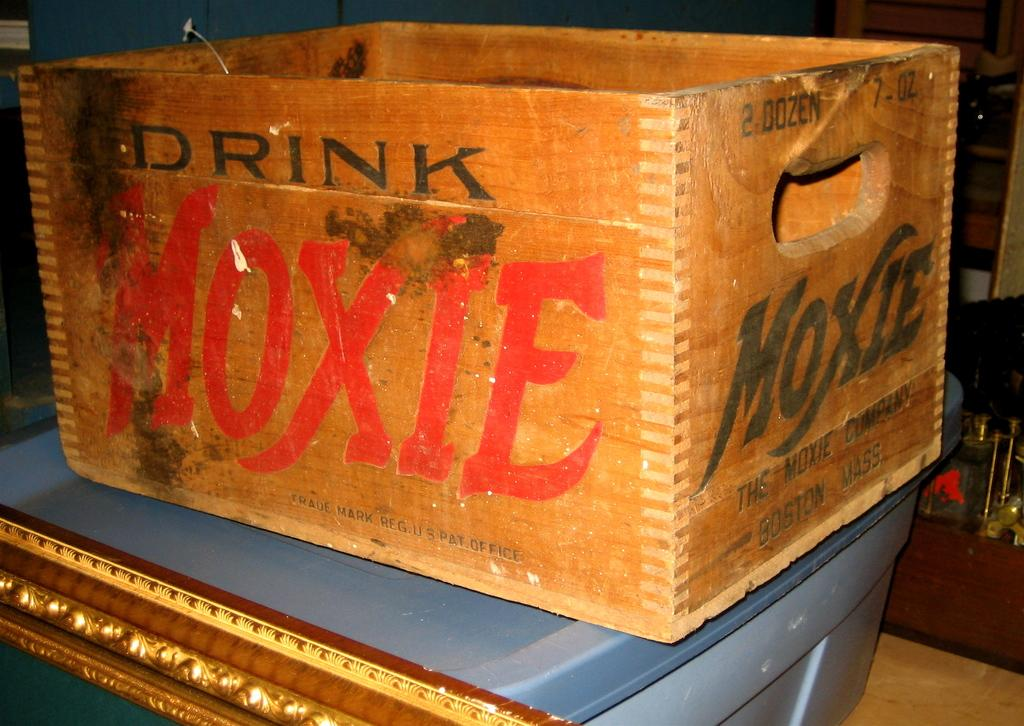<image>
Render a clear and concise summary of the photo. Drink Moxie is the slogan printed on the side of the crate. 